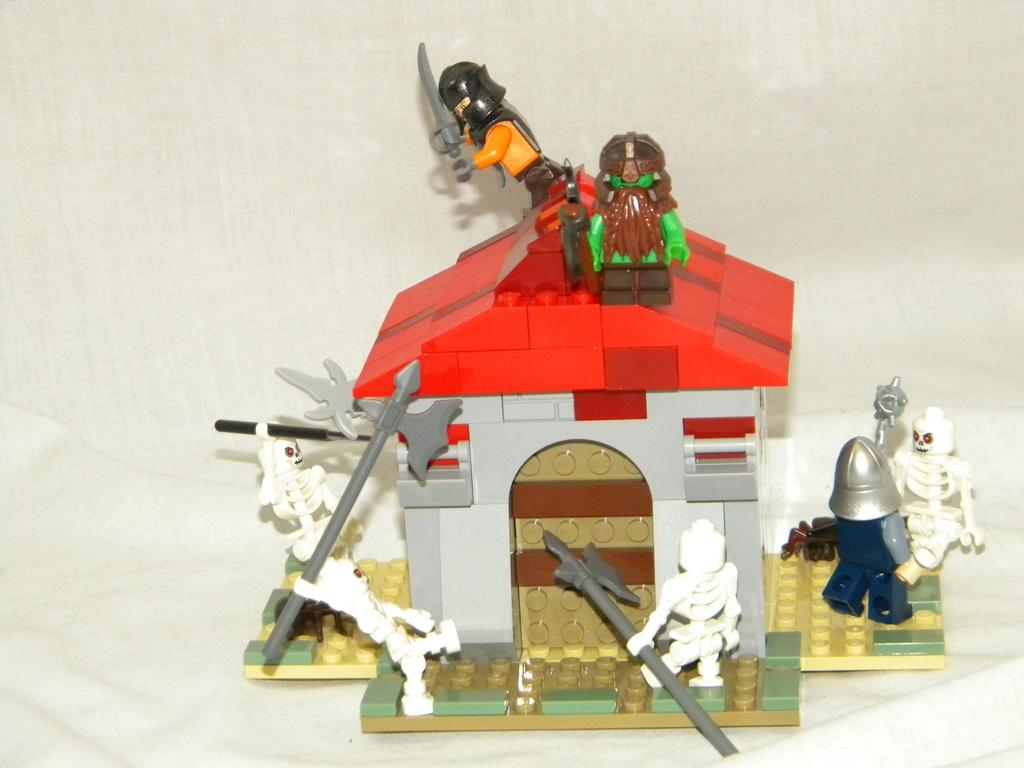What objects are located in the middle of the image? There are some toys in the middle of the image. What type of badge can be seen on the toys in the image? There is no badge present on the toys in the image. How many sticks are being used to kick the toys in the image? There are no sticks or kicking actions depicted in the image; it features toys in the middle. 